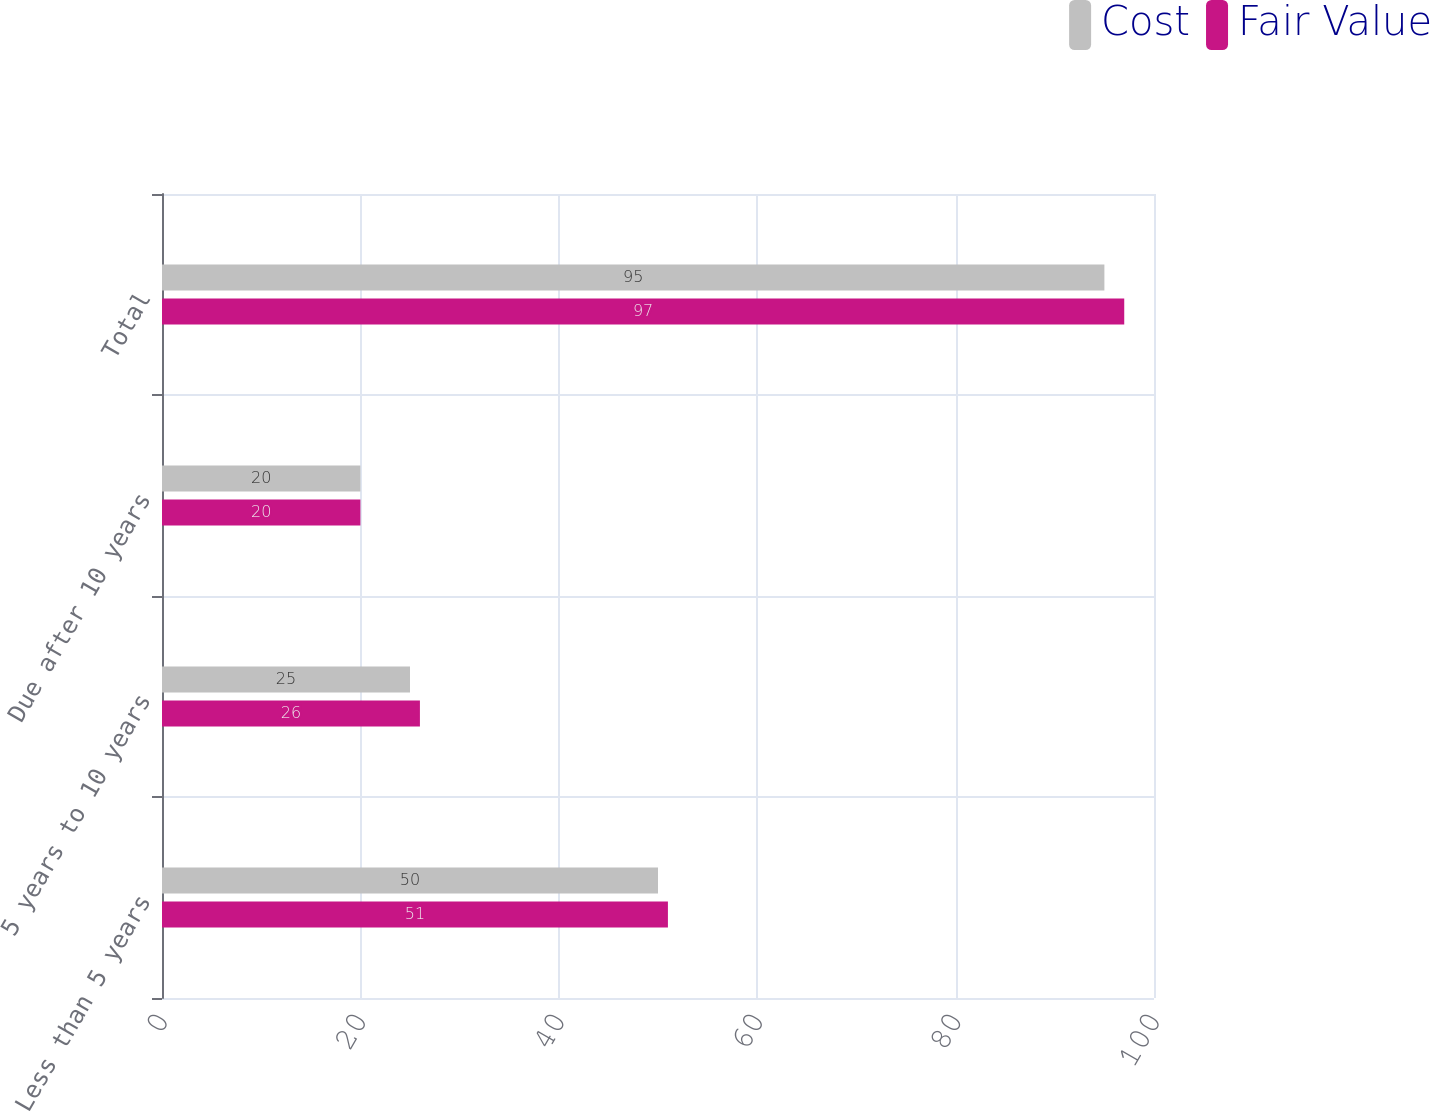Convert chart. <chart><loc_0><loc_0><loc_500><loc_500><stacked_bar_chart><ecel><fcel>Less than 5 years<fcel>5 years to 10 years<fcel>Due after 10 years<fcel>Total<nl><fcel>Cost<fcel>50<fcel>25<fcel>20<fcel>95<nl><fcel>Fair Value<fcel>51<fcel>26<fcel>20<fcel>97<nl></chart> 